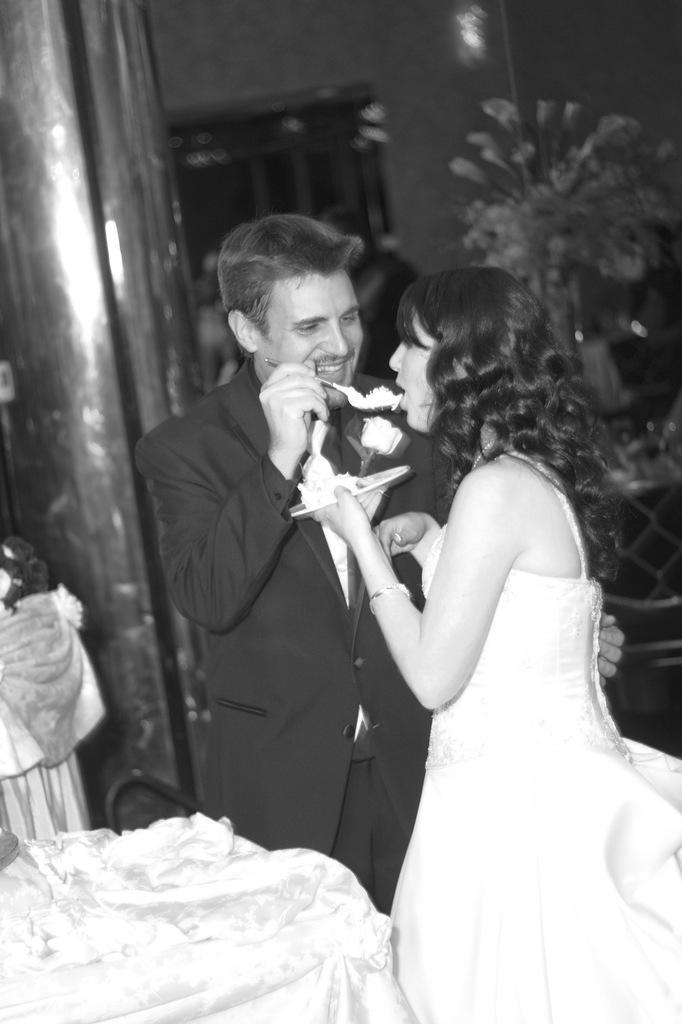How would you summarize this image in a sentence or two? In this image I can see two people holding the plate and also the spoon. In the back I can see the pillar, flower vase and also the wall. And this is a black and white image. 